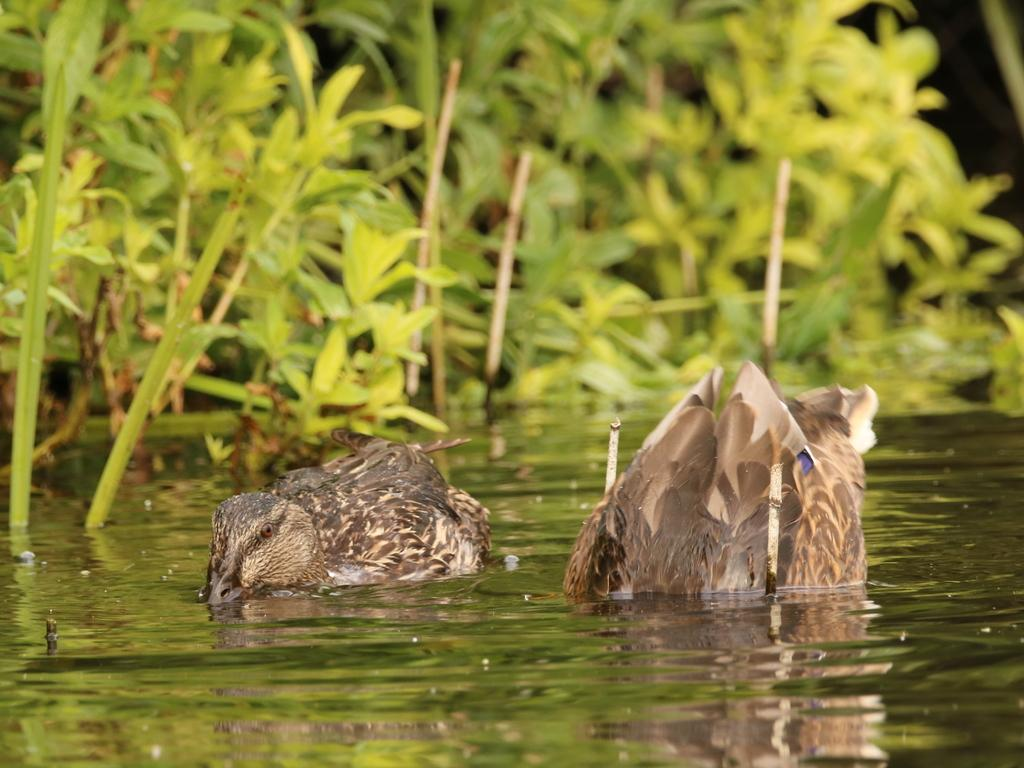What type of animals can be seen in the image? There are birds in the image. What are the birds doing in the image? The birds are swimming in the water. What can be seen in the background of the image? There are plants visible in the image. What type of glass can be seen in the image? There is no glass present in the image; it features birds swimming in the water with plants in the background. 